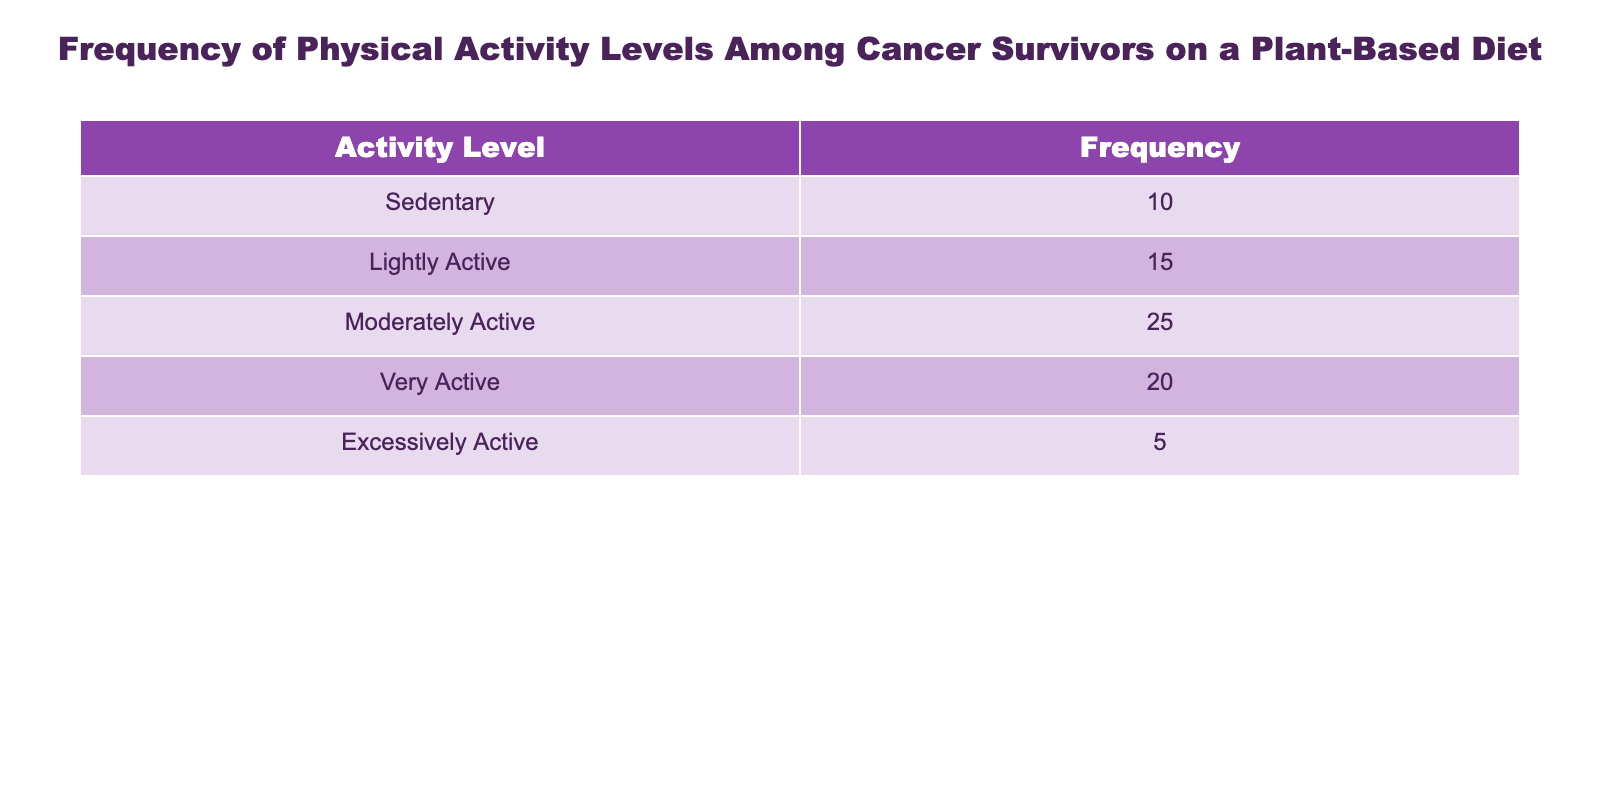What is the frequency of cancer survivors who are Sedentary? The table lists the activity levels along with their corresponding frequencies. For the Sedentary category, the frequency is directly presented as 10.
Answer: 10 What percentage of cancer survivors are Moderately Active? To find the percentage, first identify the frequency of Moderately Active (25) and the total frequency (10 + 15 + 25 + 20 + 5 = 75). The calculation is (25/75) * 100 = 33.33%.
Answer: 33.33% Is the frequency of Excessively Active cancer survivors greater than the frequency of Sedentary ones? The frequency of Excessively Active is 5, and Sedentary is 10. Since 5 is not greater than 10, the statement is false.
Answer: No What is the total frequency of cancer survivors who are Lightly Active and Moderately Active? The frequency for Lightly Active is 15 and for Moderately Active is 25. Therefore, their total frequency is 15 + 25 = 40.
Answer: 40 How many more cancer survivors are Very Active compared to Excessively Active? The frequency of Very Active is 20 and Excessively Active is 5. To find the difference, we subtract: 20 - 5 = 15.
Answer: 15 What is the ratio of Sedentary to Very Active cancer survivors? The frequency of Sedentary is 10 and Very Active is 20. The ratio can be expressed as 10:20, which simplifies to 1:2.
Answer: 1:2 Which activity level has the highest frequency, and what is that frequency? Reviewing the frequencies, Moderately Active has the highest number at 25.
Answer: Moderately Active, 25 What is the combined frequency of all active cancer survivors (Lightly Active, Moderately Active, Very Active, and Excessively Active)? The frequencies for active levels are 15 (Lightly) + 25 (Moderately) + 20 (Very) + 5 (Excessively) = 65.
Answer: 65 How many cancer survivors are not Sedentary? The total frequency of cancer survivors is 75. The Sedentary group has a frequency of 10. Therefore, the number of non-Sedentary survivors is 75 - 10 = 65.
Answer: 65 